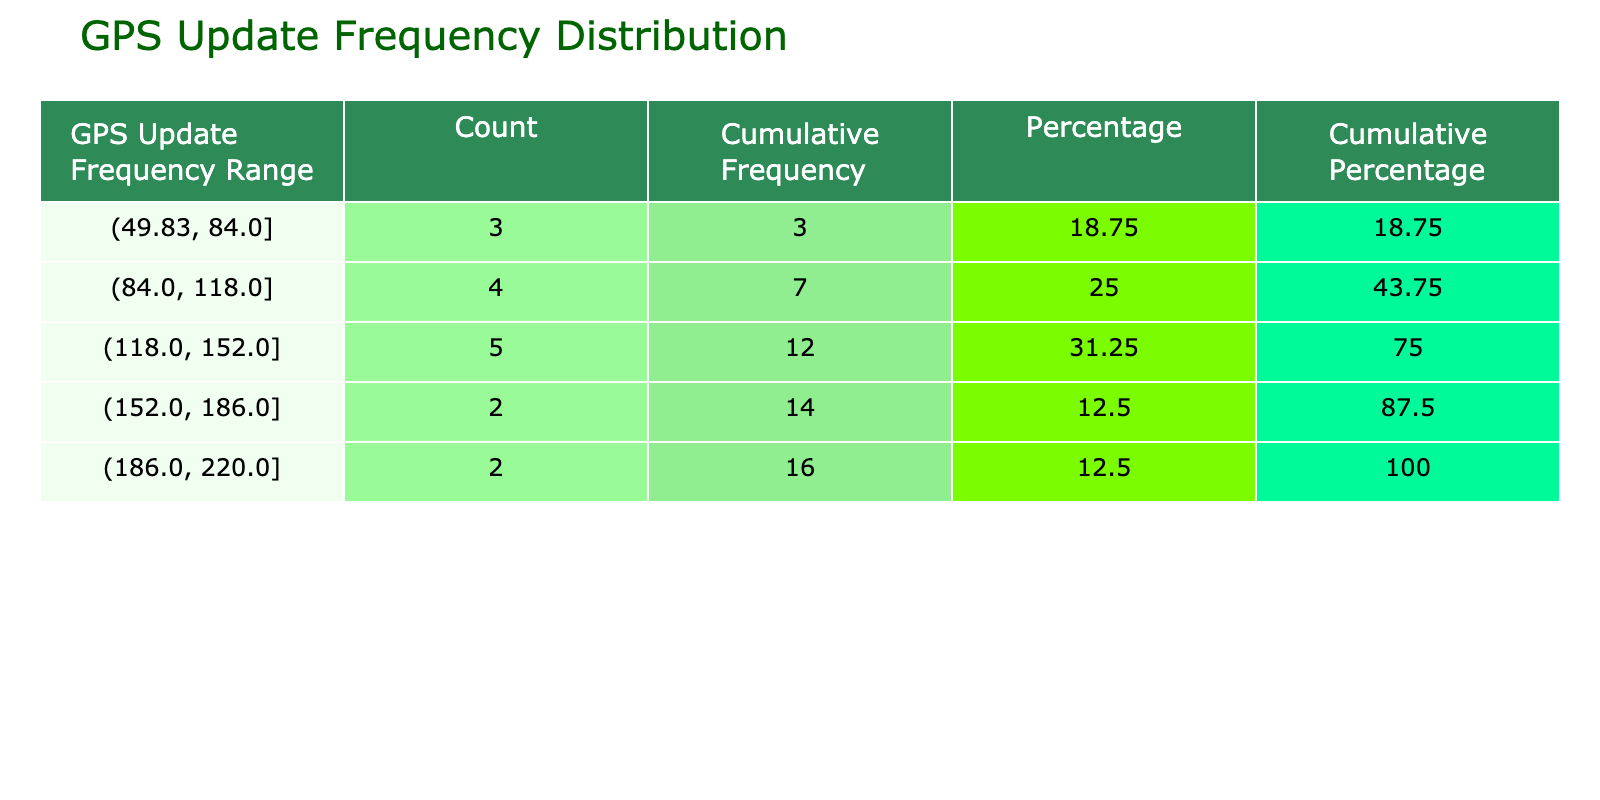What is the highest frequency of GPS updates by a user? The highest frequency in the table can be found by looking at the 'FrequencyOfGPSUpdates' column. The highest value is 220, which belongs to Liam Martinez.
Answer: 220 How many users requested between 100 and 150 GPS updates? By checking the frequency ranges in the table, we can see that '100 - 150' includes the following users: Michael Smith (120), Ethan Anderson (140), and Alice Johnson (150). This gives us a total of 3 users.
Answer: 3 What is the cumulative frequency for users with more than 120 GPS updates? To find the cumulative frequency for users with more than 120 updates, we first identify users in that range: Sarah Williams (200), David Brown (175), Alice Johnson (150), James Harris (160), Liam Martinez (220), and Ethan Anderson (140). Adding their individual counts: 220 + 200 + 175 + 160 + 150 + 140 = 1,045. Therefore, the cumulative frequency is 1,045.
Answer: 1,045 Is there a user who has exactly 60 GPS update requests? Looking at the 'FrequencyOfGPSUpdates' column, we find that Mia Wilson has exactly 60 GPS update requests listed, confirming that this statement is true.
Answer: Yes What is the average number of GPS updates for users with less than 100 requests? Reviewing the data for users with less than 100 updates, we find Mia Wilson (60), Sophia Hernandez (80), and Joshua Garcia (90). The sum of their requests is 60 + 80 + 90 = 230. Since there are 3 users, the average is 230 divided by 3, which equals approximately 76.67.
Answer: 76.67 Which user falls right in the middle of the frequency distribution in the table? To find which user's frequency falls in the middle, we need to calculate the median of all frequencies. Sorting the frequencies: 50, 60, 80, 90, 95, 100, 110, 120, 130, 140, 150, 160, 175, 200, 220 gives us 15 data points; the median will be the average of the 7th and 8th values, which are 110 and 120. Thus, the median frequency is (110 + 120) / 2 = 115.
Answer: 115 